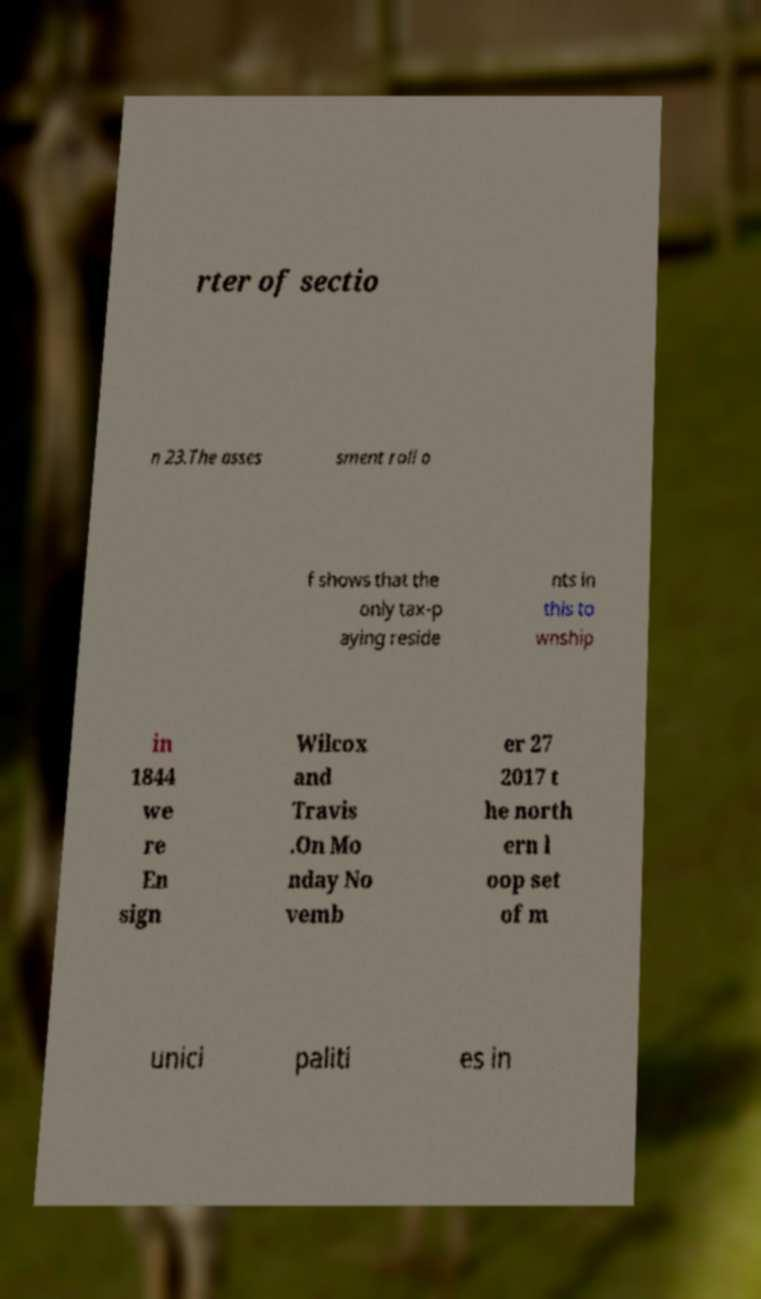There's text embedded in this image that I need extracted. Can you transcribe it verbatim? rter of sectio n 23.The asses sment roll o f shows that the only tax-p aying reside nts in this to wnship in 1844 we re En sign Wilcox and Travis .On Mo nday No vemb er 27 2017 t he north ern l oop set of m unici paliti es in 